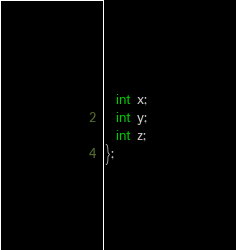Convert code to text. <code><loc_0><loc_0><loc_500><loc_500><_C++_>  int x;
  int y;
  int z;
};
</code> 